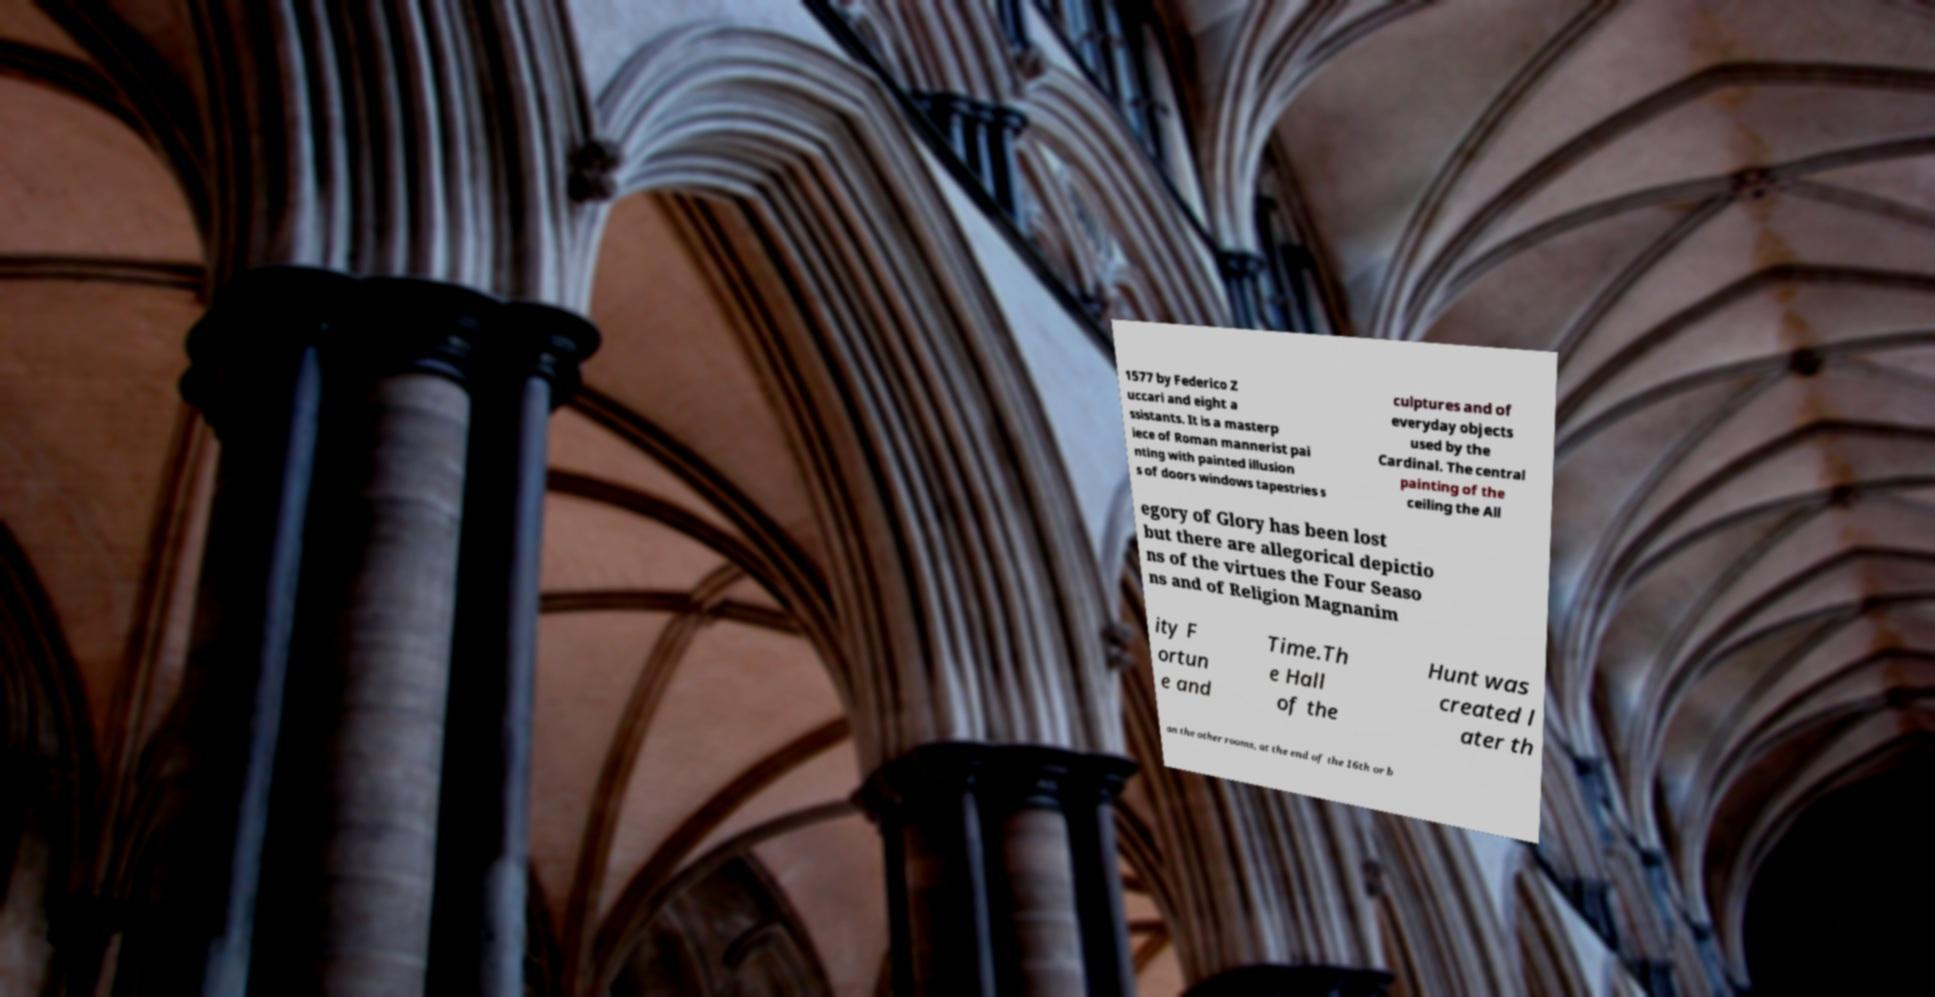Can you read and provide the text displayed in the image?This photo seems to have some interesting text. Can you extract and type it out for me? 1577 by Federico Z uccari and eight a ssistants. It is a masterp iece of Roman mannerist pai nting with painted illusion s of doors windows tapestries s culptures and of everyday objects used by the Cardinal. The central painting of the ceiling the All egory of Glory has been lost but there are allegorical depictio ns of the virtues the Four Seaso ns and of Religion Magnanim ity F ortun e and Time.Th e Hall of the Hunt was created l ater th an the other rooms, at the end of the 16th or b 